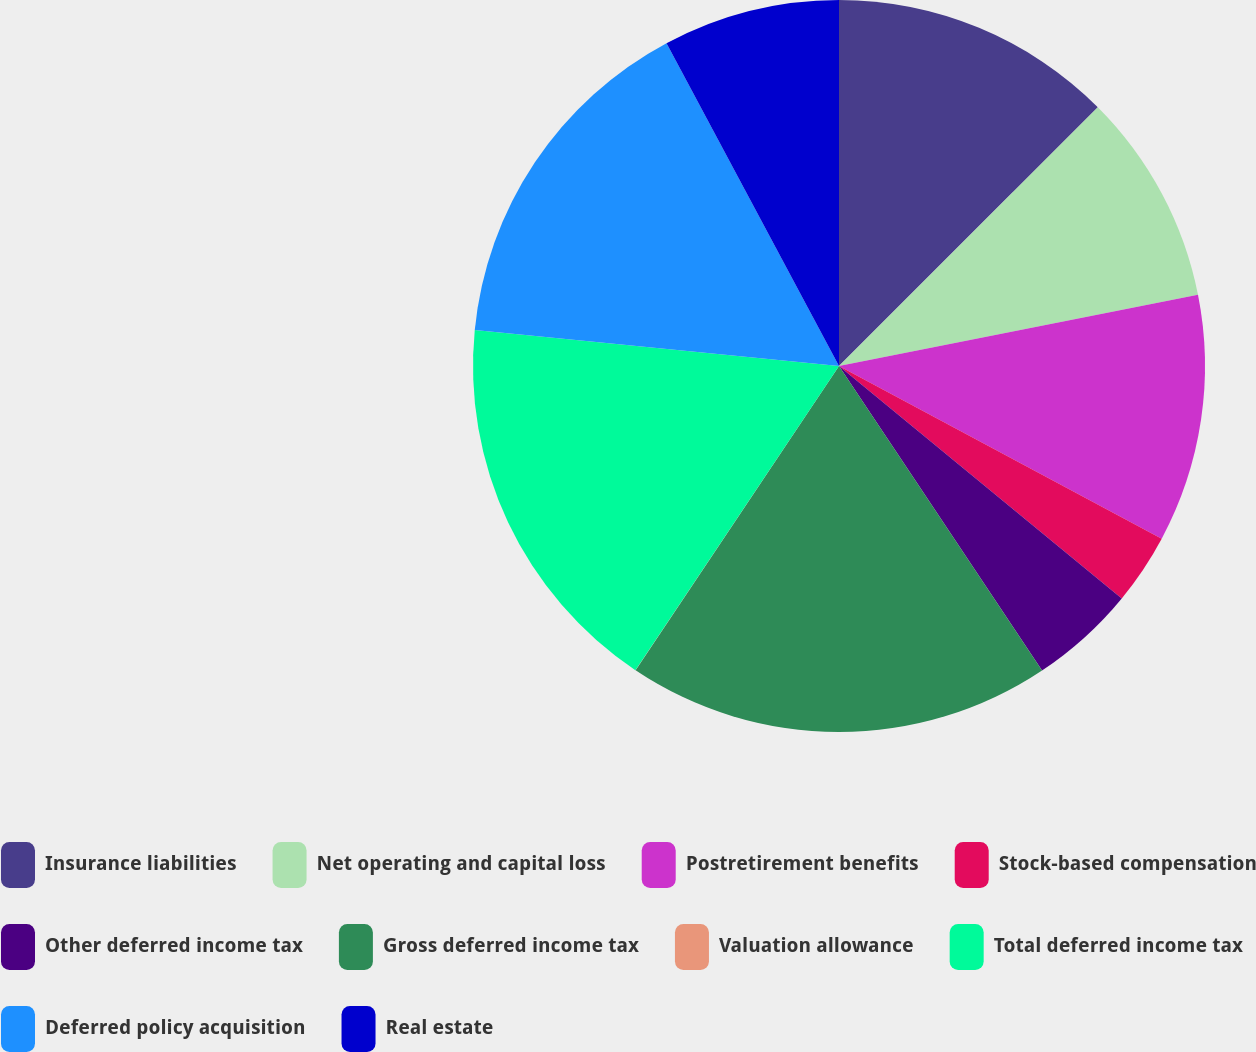Convert chart to OTSL. <chart><loc_0><loc_0><loc_500><loc_500><pie_chart><fcel>Insurance liabilities<fcel>Net operating and capital loss<fcel>Postretirement benefits<fcel>Stock-based compensation<fcel>Other deferred income tax<fcel>Gross deferred income tax<fcel>Valuation allowance<fcel>Total deferred income tax<fcel>Deferred policy acquisition<fcel>Real estate<nl><fcel>12.5%<fcel>9.38%<fcel>10.94%<fcel>3.13%<fcel>4.69%<fcel>18.74%<fcel>0.01%<fcel>17.18%<fcel>15.62%<fcel>7.81%<nl></chart> 